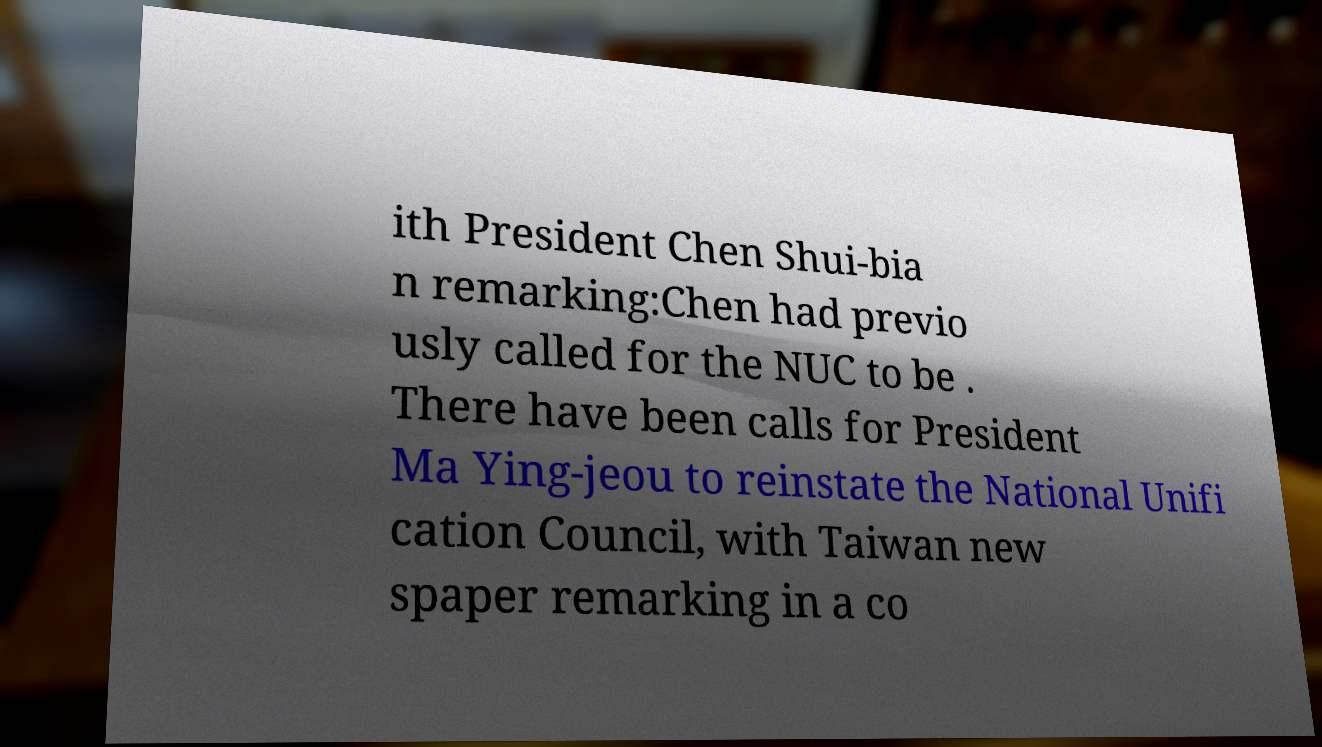Please identify and transcribe the text found in this image. ith President Chen Shui-bia n remarking:Chen had previo usly called for the NUC to be . There have been calls for President Ma Ying-jeou to reinstate the National Unifi cation Council, with Taiwan new spaper remarking in a co 